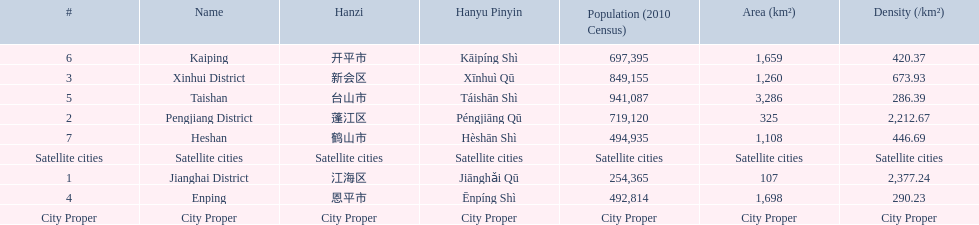What cities are there in jiangmen? Jianghai District, Pengjiang District, Xinhui District, Enping, Taishan, Kaiping, Heshan. Of those, which ones are a city proper? Jianghai District, Pengjiang District, Xinhui District. Of those, which one has the smallest area in km2? Jianghai District. 